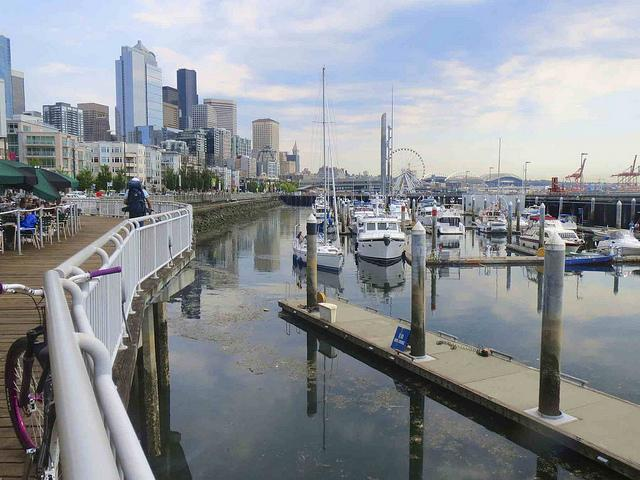What area is shown here? marina 